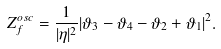Convert formula to latex. <formula><loc_0><loc_0><loc_500><loc_500>Z ^ { o s c } _ { f } = \frac { 1 } { | \eta | ^ { 2 } } | \vartheta _ { 3 } - \vartheta _ { 4 } - \vartheta _ { 2 } + \vartheta _ { 1 } | ^ { 2 } .</formula> 